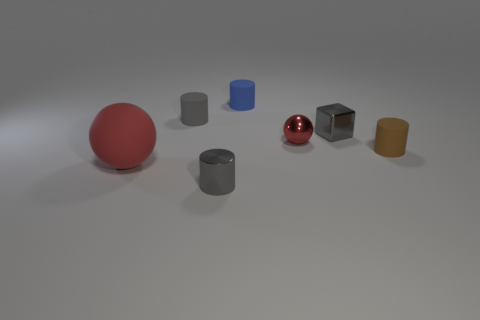Subtract all shiny cylinders. How many cylinders are left? 3 Subtract all brown cylinders. How many cylinders are left? 3 Add 3 big purple cylinders. How many objects exist? 10 Subtract 2 cylinders. How many cylinders are left? 2 Subtract all small red cubes. Subtract all small gray blocks. How many objects are left? 6 Add 3 blocks. How many blocks are left? 4 Add 2 large objects. How many large objects exist? 3 Subtract 1 brown cylinders. How many objects are left? 6 Subtract all cylinders. How many objects are left? 3 Subtract all purple blocks. Subtract all green spheres. How many blocks are left? 1 